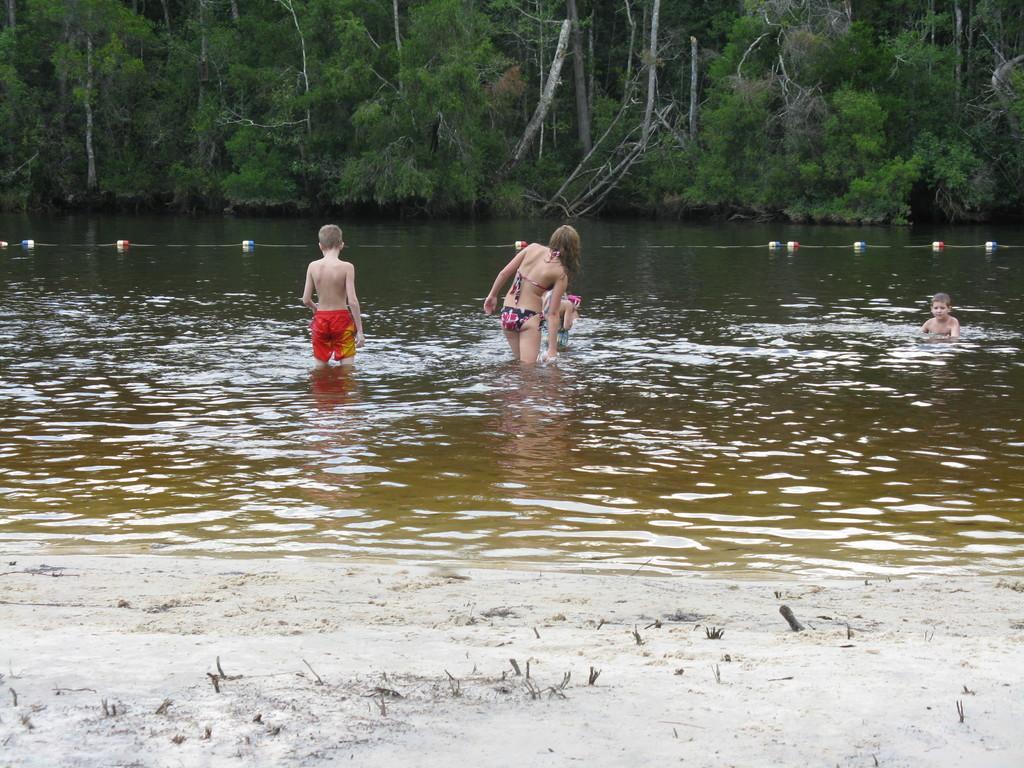Describe this image in one or two sentences. In this image there are some people standing and playing in the water, at the middle there is a holding rope and there are so many trees at the back. 